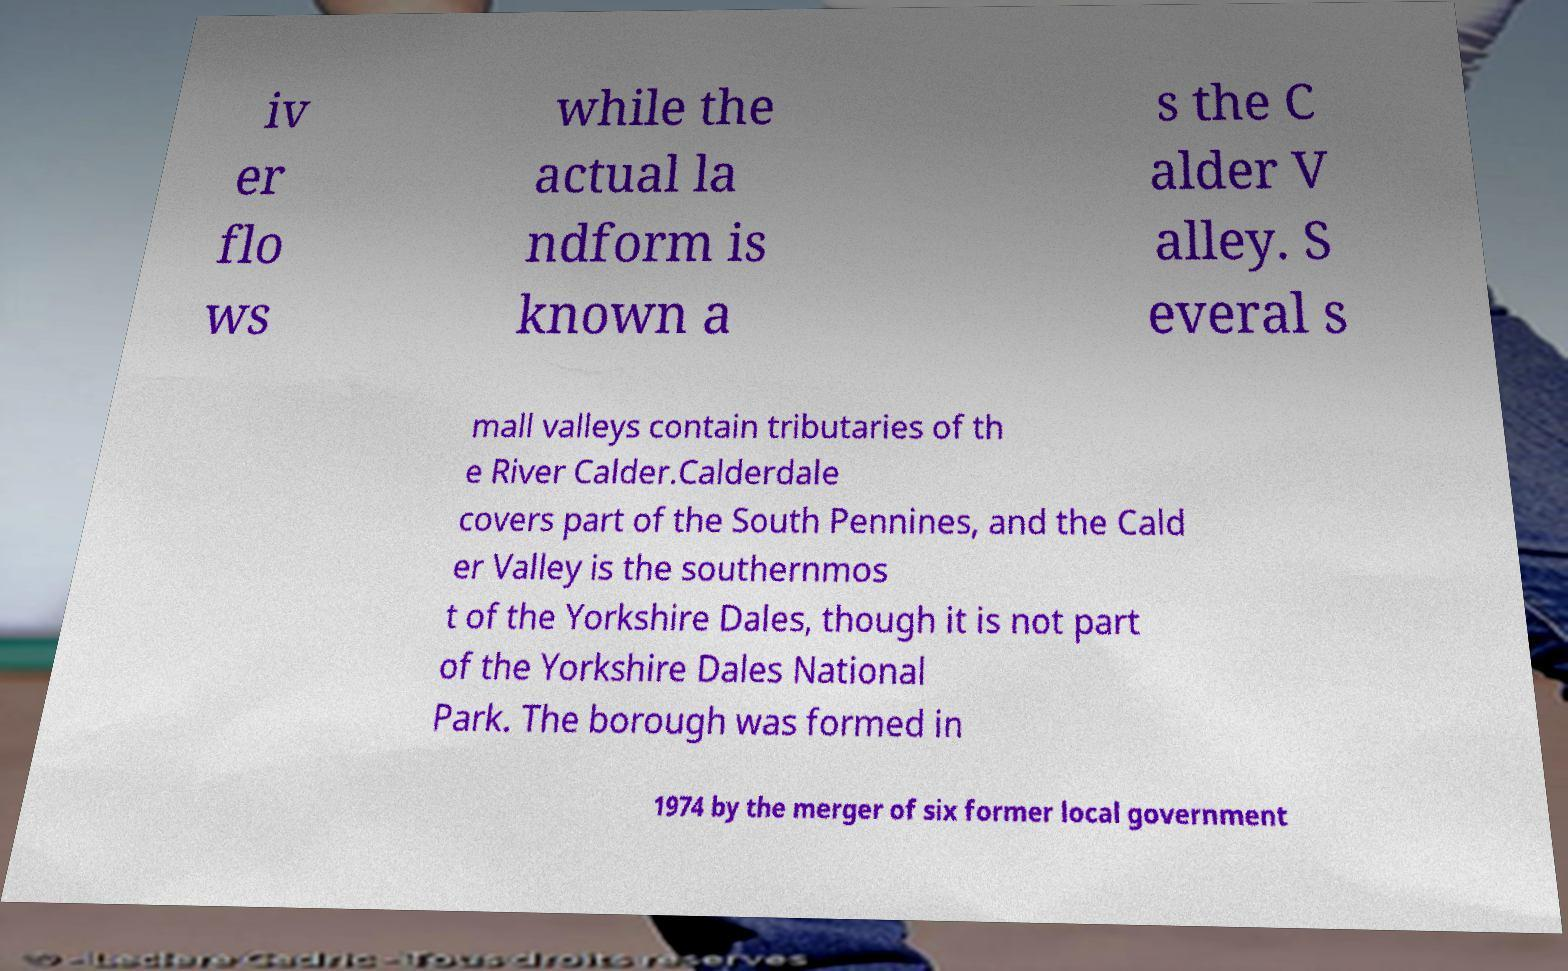Can you read and provide the text displayed in the image?This photo seems to have some interesting text. Can you extract and type it out for me? iv er flo ws while the actual la ndform is known a s the C alder V alley. S everal s mall valleys contain tributaries of th e River Calder.Calderdale covers part of the South Pennines, and the Cald er Valley is the southernmos t of the Yorkshire Dales, though it is not part of the Yorkshire Dales National Park. The borough was formed in 1974 by the merger of six former local government 